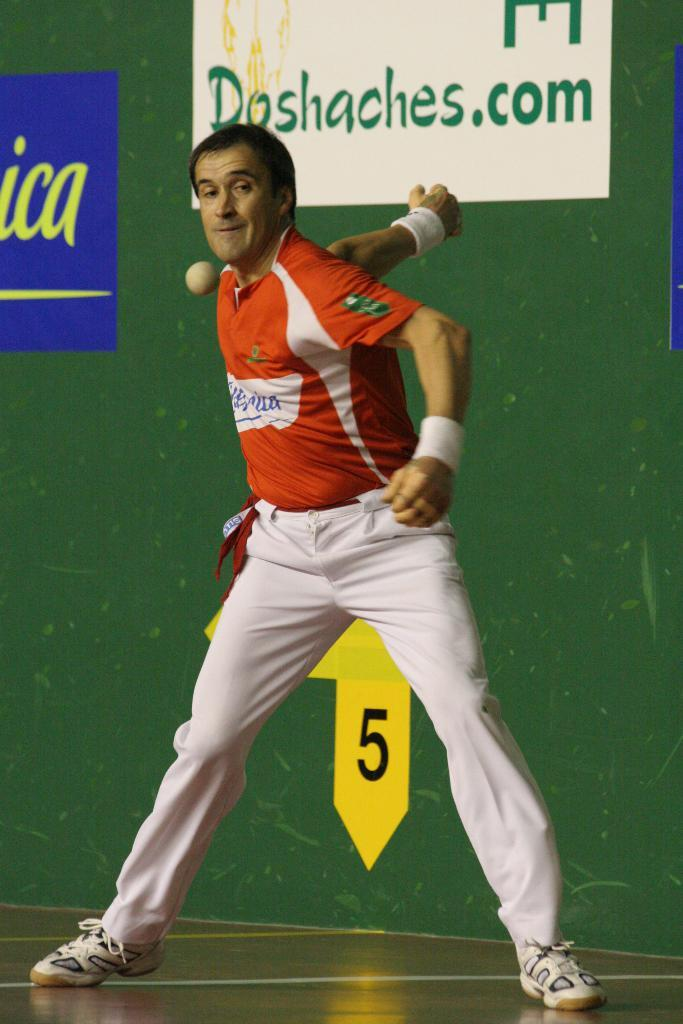<image>
Give a short and clear explanation of the subsequent image. An man in a red shirt is playing a game, in front of a green wall with a poster on it that has the website Dashaches.com printed on it. 